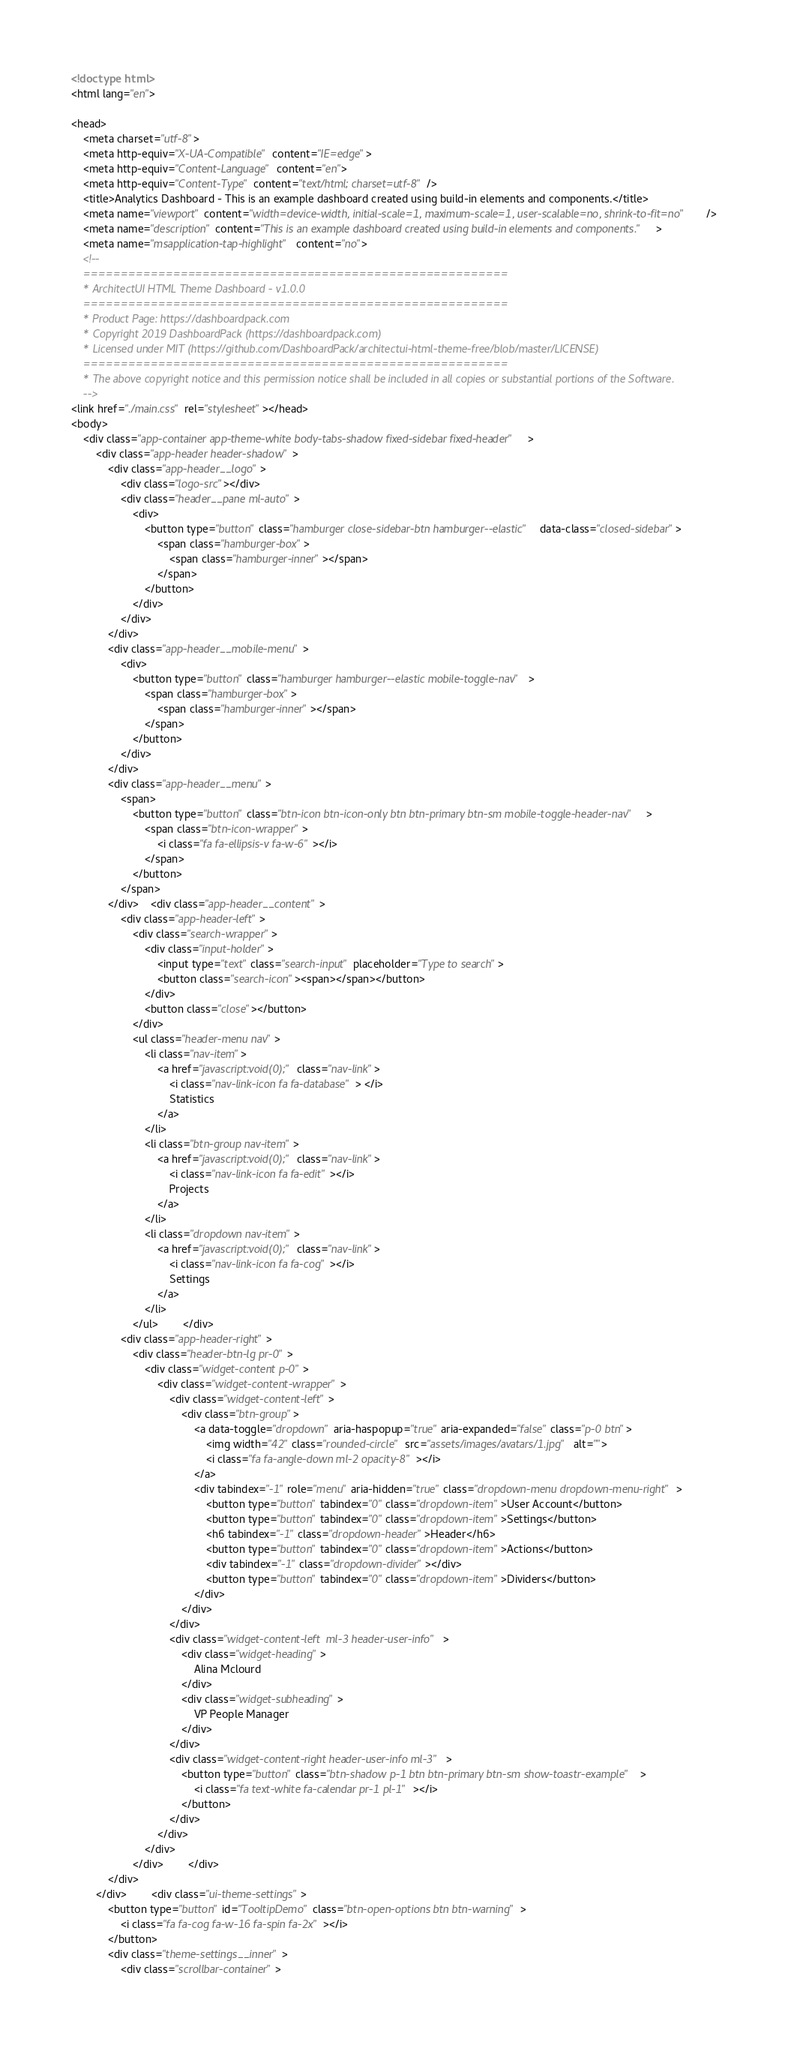Convert code to text. <code><loc_0><loc_0><loc_500><loc_500><_HTML_><!doctype html>
<html lang="en">

<head>
    <meta charset="utf-8">
    <meta http-equiv="X-UA-Compatible" content="IE=edge">
    <meta http-equiv="Content-Language" content="en">
    <meta http-equiv="Content-Type" content="text/html; charset=utf-8"/>
    <title>Analytics Dashboard - This is an example dashboard created using build-in elements and components.</title>
    <meta name="viewport" content="width=device-width, initial-scale=1, maximum-scale=1, user-scalable=no, shrink-to-fit=no" />
    <meta name="description" content="This is an example dashboard created using build-in elements and components.">
    <meta name="msapplication-tap-highlight" content="no">
    <!--
    =========================================================
    * ArchitectUI HTML Theme Dashboard - v1.0.0
    =========================================================
    * Product Page: https://dashboardpack.com
    * Copyright 2019 DashboardPack (https://dashboardpack.com)
    * Licensed under MIT (https://github.com/DashboardPack/architectui-html-theme-free/blob/master/LICENSE)
    =========================================================
    * The above copyright notice and this permission notice shall be included in all copies or substantial portions of the Software.
    -->
<link href="./main.css" rel="stylesheet"></head>
<body>
    <div class="app-container app-theme-white body-tabs-shadow fixed-sidebar fixed-header">
        <div class="app-header header-shadow">
            <div class="app-header__logo">
                <div class="logo-src"></div>
                <div class="header__pane ml-auto">
                    <div>
                        <button type="button" class="hamburger close-sidebar-btn hamburger--elastic" data-class="closed-sidebar">
                            <span class="hamburger-box">
                                <span class="hamburger-inner"></span>
                            </span>
                        </button>
                    </div>
                </div>
            </div>
            <div class="app-header__mobile-menu">
                <div>
                    <button type="button" class="hamburger hamburger--elastic mobile-toggle-nav">
                        <span class="hamburger-box">
                            <span class="hamburger-inner"></span>
                        </span>
                    </button>
                </div>
            </div>
            <div class="app-header__menu">
                <span>
                    <button type="button" class="btn-icon btn-icon-only btn btn-primary btn-sm mobile-toggle-header-nav">
                        <span class="btn-icon-wrapper">
                            <i class="fa fa-ellipsis-v fa-w-6"></i>
                        </span>
                    </button>
                </span>
            </div>    <div class="app-header__content">
                <div class="app-header-left">
                    <div class="search-wrapper">
                        <div class="input-holder">
                            <input type="text" class="search-input" placeholder="Type to search">
                            <button class="search-icon"><span></span></button>
                        </div>
                        <button class="close"></button>
                    </div>
                    <ul class="header-menu nav">
                        <li class="nav-item">
                            <a href="javascript:void(0);" class="nav-link">
                                <i class="nav-link-icon fa fa-database"> </i>
                                Statistics
                            </a>
                        </li>
                        <li class="btn-group nav-item">
                            <a href="javascript:void(0);" class="nav-link">
                                <i class="nav-link-icon fa fa-edit"></i>
                                Projects
                            </a>
                        </li>
                        <li class="dropdown nav-item">
                            <a href="javascript:void(0);" class="nav-link">
                                <i class="nav-link-icon fa fa-cog"></i>
                                Settings
                            </a>
                        </li>
                    </ul>        </div>
                <div class="app-header-right">
                    <div class="header-btn-lg pr-0">
                        <div class="widget-content p-0">
                            <div class="widget-content-wrapper">
                                <div class="widget-content-left">
                                    <div class="btn-group">
                                        <a data-toggle="dropdown" aria-haspopup="true" aria-expanded="false" class="p-0 btn">
                                            <img width="42" class="rounded-circle" src="assets/images/avatars/1.jpg" alt="">
                                            <i class="fa fa-angle-down ml-2 opacity-8"></i>
                                        </a>
                                        <div tabindex="-1" role="menu" aria-hidden="true" class="dropdown-menu dropdown-menu-right">
                                            <button type="button" tabindex="0" class="dropdown-item">User Account</button>
                                            <button type="button" tabindex="0" class="dropdown-item">Settings</button>
                                            <h6 tabindex="-1" class="dropdown-header">Header</h6>
                                            <button type="button" tabindex="0" class="dropdown-item">Actions</button>
                                            <div tabindex="-1" class="dropdown-divider"></div>
                                            <button type="button" tabindex="0" class="dropdown-item">Dividers</button>
                                        </div>
                                    </div>
                                </div>
                                <div class="widget-content-left  ml-3 header-user-info">
                                    <div class="widget-heading">
                                        Alina Mclourd
                                    </div>
                                    <div class="widget-subheading">
                                        VP People Manager
                                    </div>
                                </div>
                                <div class="widget-content-right header-user-info ml-3">
                                    <button type="button" class="btn-shadow p-1 btn btn-primary btn-sm show-toastr-example">
                                        <i class="fa text-white fa-calendar pr-1 pl-1"></i>
                                    </button>
                                </div>
                            </div>
                        </div>
                    </div>        </div>
            </div>
        </div>        <div class="ui-theme-settings">
            <button type="button" id="TooltipDemo" class="btn-open-options btn btn-warning">
                <i class="fa fa-cog fa-w-16 fa-spin fa-2x"></i>
            </button>
            <div class="theme-settings__inner">
                <div class="scrollbar-container"></code> 